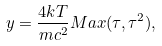Convert formula to latex. <formula><loc_0><loc_0><loc_500><loc_500>y = \frac { 4 k T } { m c ^ { 2 } } M a x ( \tau , \tau ^ { 2 } ) ,</formula> 